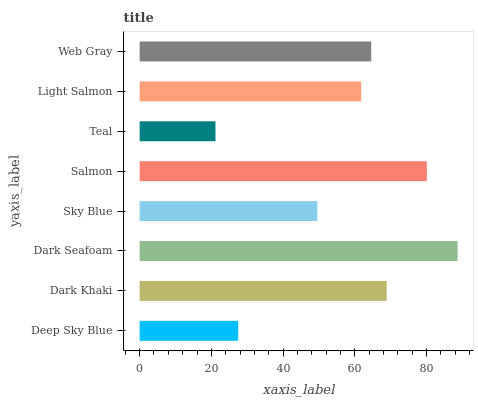Is Teal the minimum?
Answer yes or no. Yes. Is Dark Seafoam the maximum?
Answer yes or no. Yes. Is Dark Khaki the minimum?
Answer yes or no. No. Is Dark Khaki the maximum?
Answer yes or no. No. Is Dark Khaki greater than Deep Sky Blue?
Answer yes or no. Yes. Is Deep Sky Blue less than Dark Khaki?
Answer yes or no. Yes. Is Deep Sky Blue greater than Dark Khaki?
Answer yes or no. No. Is Dark Khaki less than Deep Sky Blue?
Answer yes or no. No. Is Web Gray the high median?
Answer yes or no. Yes. Is Light Salmon the low median?
Answer yes or no. Yes. Is Light Salmon the high median?
Answer yes or no. No. Is Deep Sky Blue the low median?
Answer yes or no. No. 